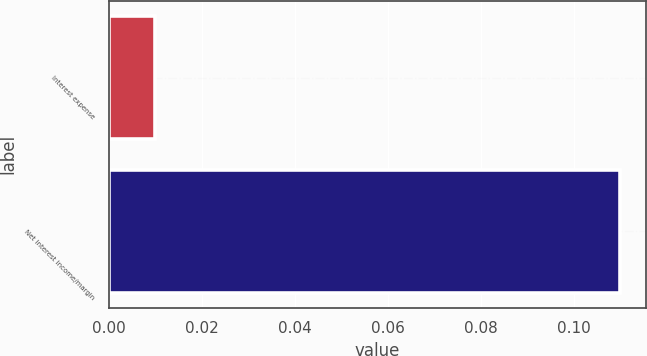Convert chart to OTSL. <chart><loc_0><loc_0><loc_500><loc_500><bar_chart><fcel>Interest expense<fcel>Net interest income/margin<nl><fcel>0.01<fcel>0.11<nl></chart> 